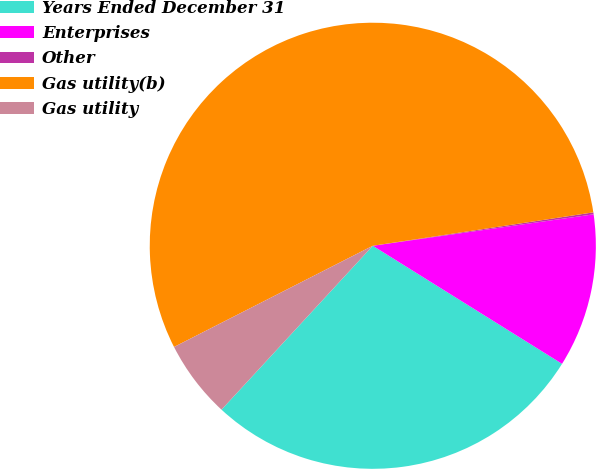Convert chart to OTSL. <chart><loc_0><loc_0><loc_500><loc_500><pie_chart><fcel>Years Ended December 31<fcel>Enterprises<fcel>Other<fcel>Gas utility(b)<fcel>Gas utility<nl><fcel>27.99%<fcel>11.13%<fcel>0.14%<fcel>55.11%<fcel>5.64%<nl></chart> 